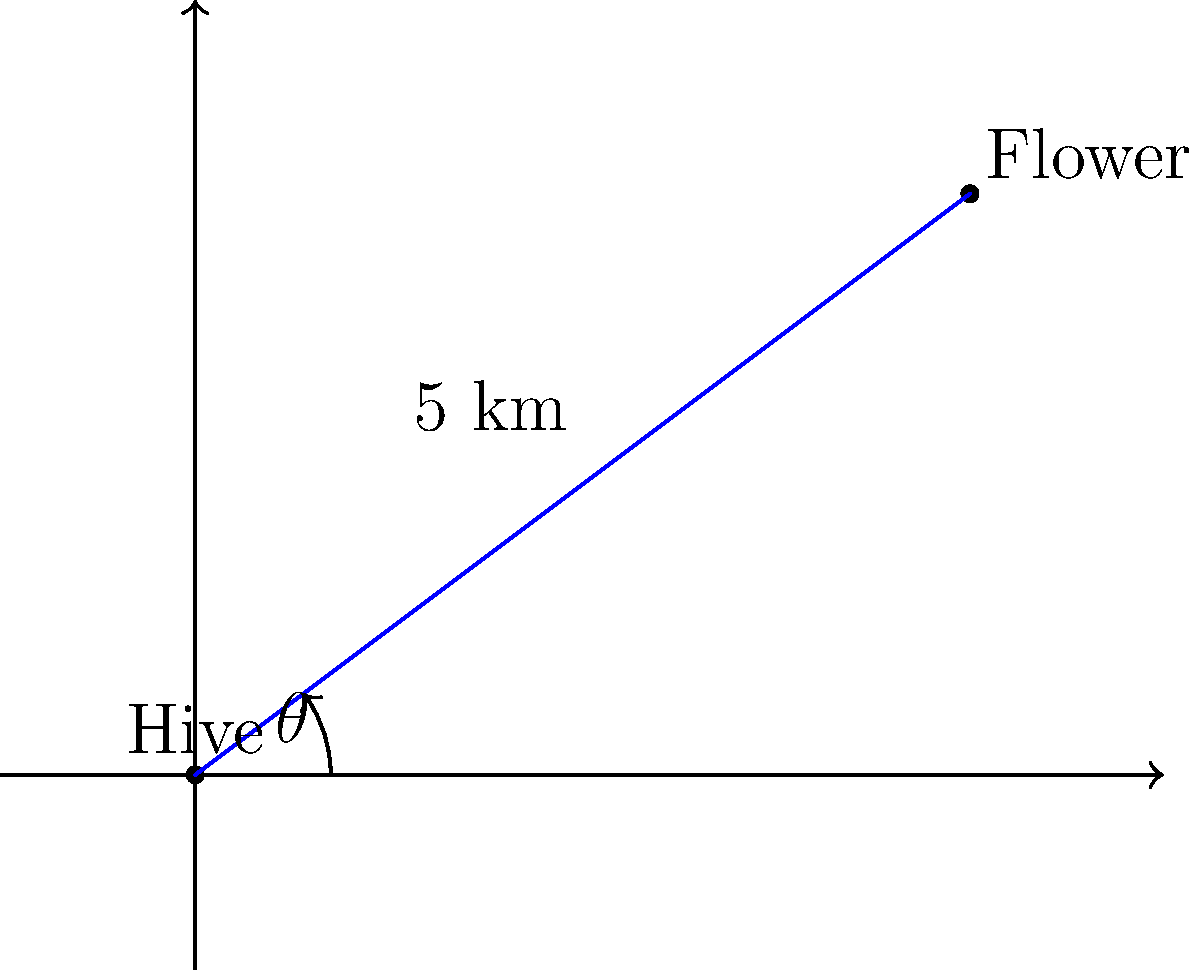A scout bee has discovered a new flower patch 5 km away from the hive. The flower's location relative to the hive can be represented on a coordinate plane, where the hive is at (0,0) and the flower is at (4,3). What is the angle (in degrees, rounded to the nearest whole number) that the bee should use in its waggle dance to communicate the flower's direction to other bees? Assume that 0° corresponds to the positive x-axis, and angles increase counterclockwise. To solve this problem, we need to follow these steps:

1. Identify the coordinates:
   Hive: (0, 0)
   Flower: (4, 3)

2. Calculate the angle using the arctangent function:
   $\theta = \arctan(\frac{y}{x})$
   
   Where:
   $y$ is the vertical distance (3)
   $x$ is the horizontal distance (4)

3. Plug in the values:
   $\theta = \arctan(\frac{3}{4})$

4. Calculate the result:
   $\theta \approx 0.6435$ radians

5. Convert radians to degrees:
   $\theta_{degrees} = \theta_{radians} \times \frac{180°}{\pi}$
   $\theta_{degrees} \approx 0.6435 \times \frac{180°}{\pi} \approx 36.87°$

6. Round to the nearest whole number:
   $\theta_{rounded} = 37°$

Therefore, the bee should use an angle of 37° in its waggle dance to communicate the flower's direction to other bees.
Answer: 37° 